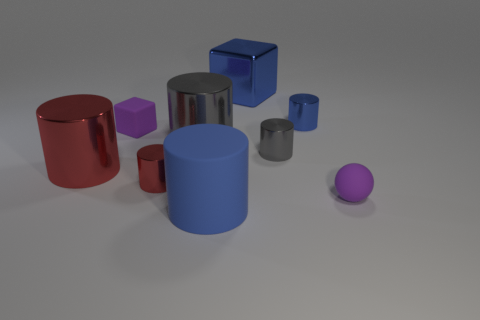What number of things are the same size as the purple cube?
Provide a succinct answer. 4. Does the blue cylinder behind the big blue cylinder have the same material as the small gray thing?
Provide a succinct answer. Yes. Are there fewer small matte cubes behind the big blue shiny thing than large purple balls?
Give a very brief answer. No. What shape is the rubber object on the right side of the blue rubber cylinder?
Offer a very short reply. Sphere. What is the shape of the gray object that is the same size as the purple ball?
Make the answer very short. Cylinder. Are there any matte objects that have the same shape as the tiny gray metallic object?
Offer a terse response. Yes. There is a large thing to the left of the purple cube; is its shape the same as the rubber thing that is on the left side of the large matte cylinder?
Give a very brief answer. No. There is a blue object that is the same size as the blue shiny cube; what material is it?
Make the answer very short. Rubber. How many other objects are the same material as the large cube?
Provide a succinct answer. 5. There is a tiny rubber object to the left of the purple sphere behind the big blue rubber object; what shape is it?
Offer a terse response. Cube. 